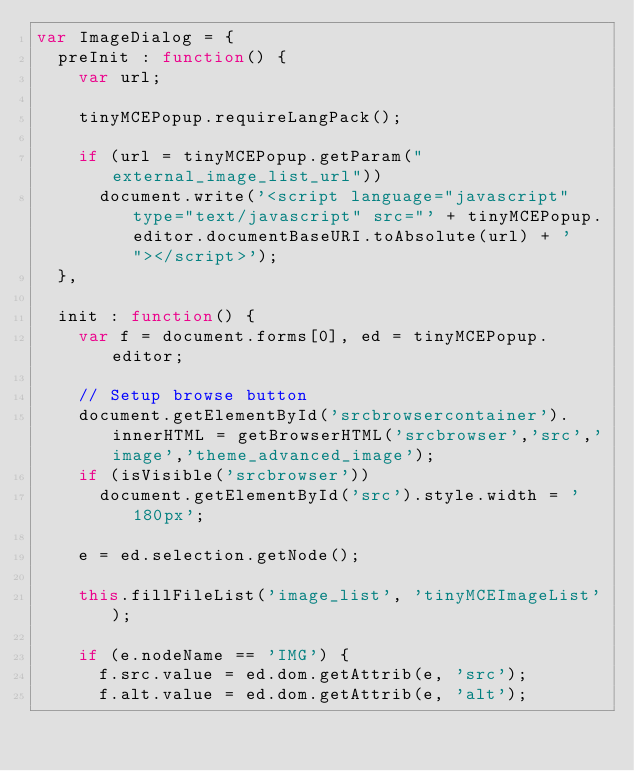Convert code to text. <code><loc_0><loc_0><loc_500><loc_500><_JavaScript_>var ImageDialog = {
	preInit : function() {
		var url;

		tinyMCEPopup.requireLangPack();

		if (url = tinyMCEPopup.getParam("external_image_list_url"))
			document.write('<script language="javascript" type="text/javascript" src="' + tinyMCEPopup.editor.documentBaseURI.toAbsolute(url) + '"></script>');
	},

	init : function() {
		var f = document.forms[0], ed = tinyMCEPopup.editor;

		// Setup browse button
		document.getElementById('srcbrowsercontainer').innerHTML = getBrowserHTML('srcbrowser','src','image','theme_advanced_image');
		if (isVisible('srcbrowser'))
			document.getElementById('src').style.width = '180px';

		e = ed.selection.getNode();

		this.fillFileList('image_list', 'tinyMCEImageList');

		if (e.nodeName == 'IMG') {
			f.src.value = ed.dom.getAttrib(e, 'src');
			f.alt.value = ed.dom.getAttrib(e, 'alt');</code> 